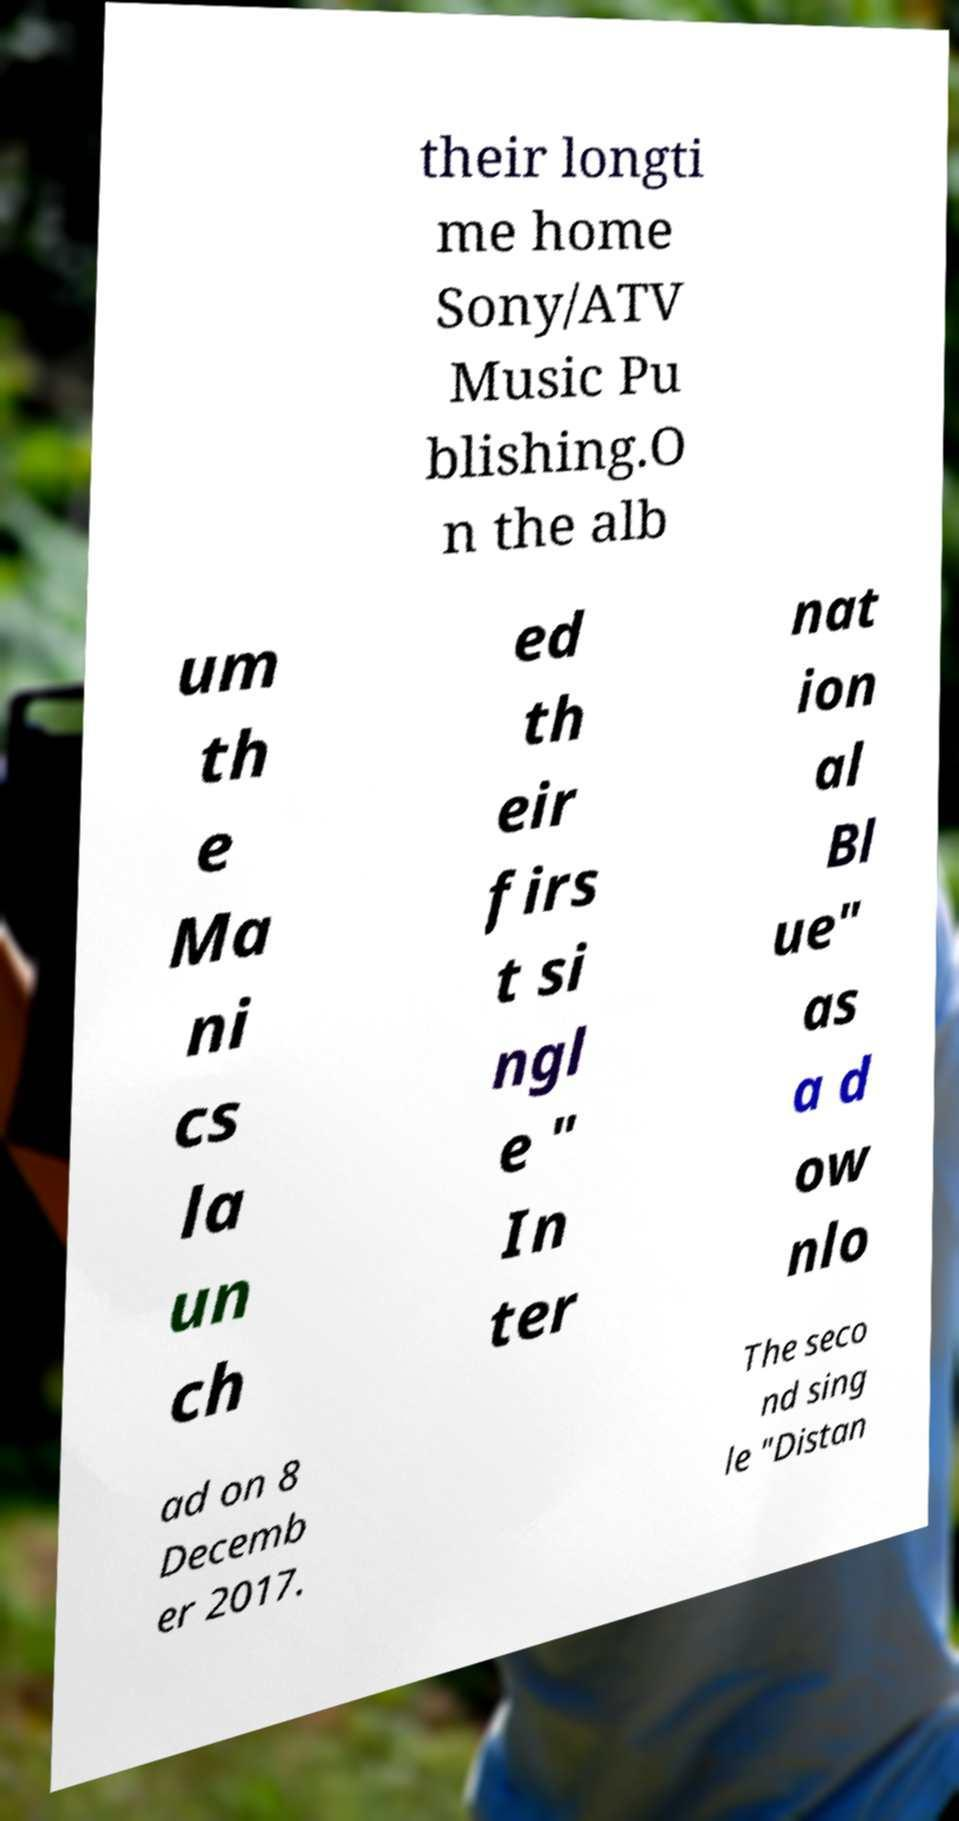There's text embedded in this image that I need extracted. Can you transcribe it verbatim? their longti me home Sony/ATV Music Pu blishing.O n the alb um th e Ma ni cs la un ch ed th eir firs t si ngl e " In ter nat ion al Bl ue" as a d ow nlo ad on 8 Decemb er 2017. The seco nd sing le "Distan 